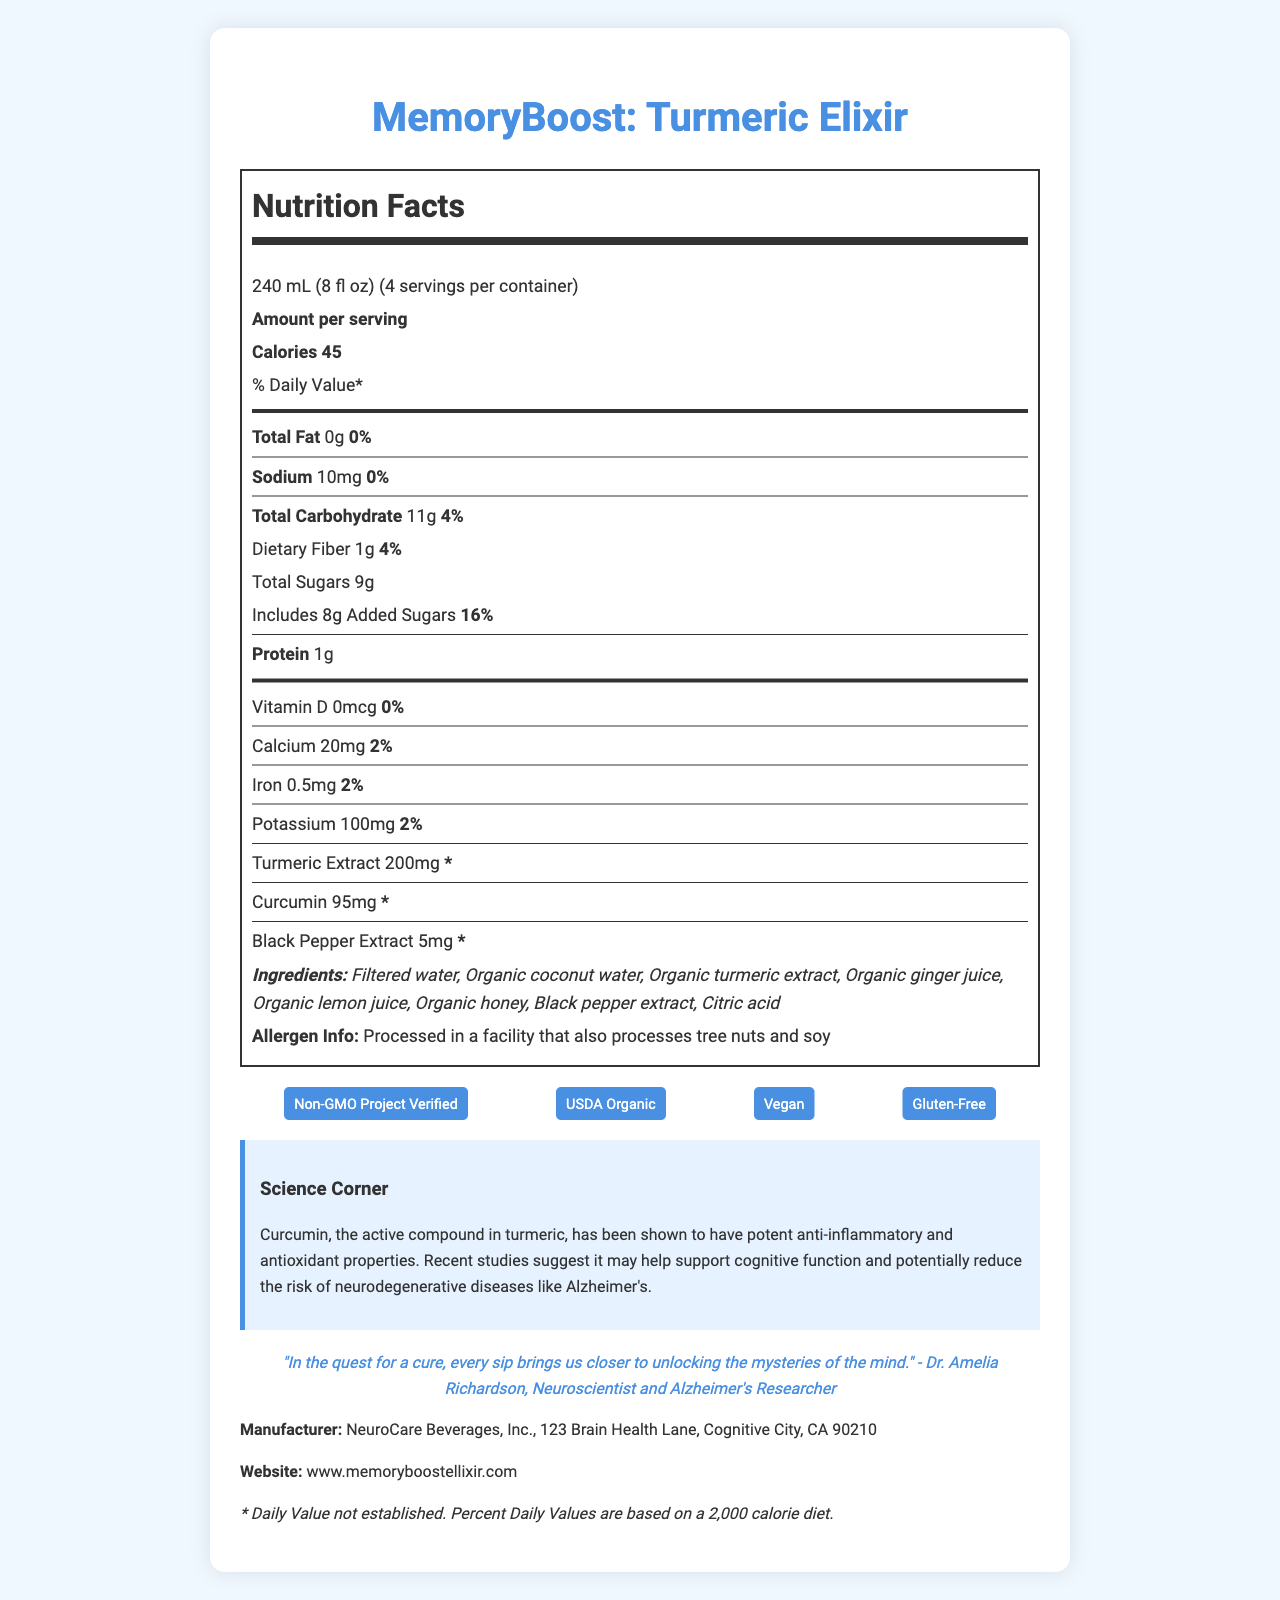what is the product name? The product name is displayed prominently at the top of the document.
Answer: MemoryBoost: Turmeric Elixir what is the serving size? The serving size is stated under the Nutrition Facts heading.
Answer: 240 mL (8 fl oz) how many calories are in one serving? The amount of calories per serving is listed right below the "Amount per serving" section.
Answer: 45 how much total fat is in a serving? The total fat content per serving is listed as 0g with a daily value of 0%.
Answer: 0g what are the first three ingredients of this beverage? The ingredient list shows these as the first three items.
Answer: Filtered water, Organic coconut water, Organic turmeric extract which claim or certification does the product not have? A. Non-GMO B. Organic C. Low Sugar D. Vegan The document lists certifications such as "Non-GMO Project Verified", "USDA Organic", "Vegan", and "Gluten-Free", but does not mention "Low Sugar."
Answer: C. Low Sugar how many grams of protein are in one serving? The protein content per serving is listed as 1g in the Nutrition Facts section.
Answer: 1g which of the following is present in the beverage? A. Vitamin C B. Vitamin D C. Iron D. Magnesium The document lists Iron with an amount of 0.5mg and a daily value of 2%.
Answer: C. Iron are there any added sugars in this product? The Nutrition Facts label indicates there are 8g of added sugars, which accounts for 16% of the daily value.
Answer: Yes does the product contain any allergens? The allergen information notes that the product is processed in a facility that also processes tree nuts and soy.
Answer: Yes summarize the main idea of the document. The document is comprehensive, presenting the product's nutritional details, health benefits, and additional key information.
Answer: The document provides detailed nutritional information about MemoryBoost: Turmeric Elixir, a turmeric-infused beverage with anti-inflammatory properties. It lists the serving size, calorie content, macronutrient amounts, ingredients, claims and certifications, and manufacturer details. The Science Corner highlights the cognitive benefits of curcumin, and an inspirational quote is included. how does the presence of curcumin benefit the drink? The Science Corner section of the document states the benefits of curcumin, emphasizing its potential impact on cognitive health.
Answer: Curcumin has anti-inflammatory and antioxidant properties, and it may support cognitive function and potentially reduce the risk of neurodegenerative diseases like Alzheimer's. where is the manufacturer located? The manufacturer's address is provided at the bottom of the document under "Manufacturer."
Answer: 123 Brain Health Lane, Cognitive City, CA 90210 how much potassium is in each serving? The Nutrition Facts label lists the potassium content as 100mg per serving, with a daily value of 2%.
Answer: 100mg how is the "MemoryBoost: Turmeric Elixir" product certified? The claims and certifications section lists these certifications.
Answer: Non-GMO Project Verified, USDA Organic, Vegan, Gluten-Free can you find the expiration date of the product? The document does not provide information about the expiration date, so it cannot be determined based on the provided visual information.
Answer: Cannot be determined 